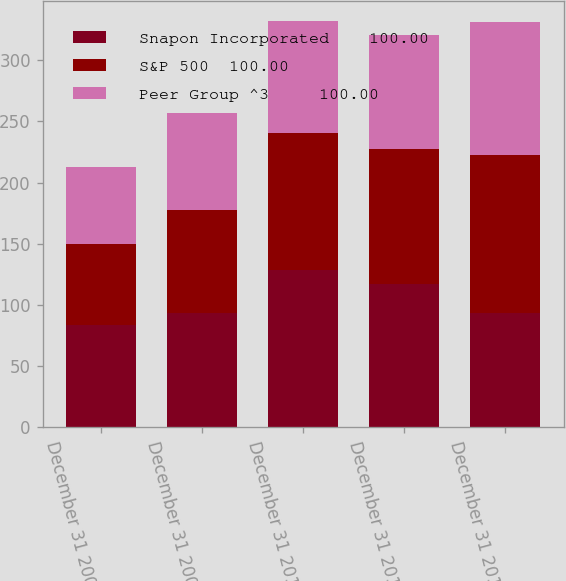Convert chart to OTSL. <chart><loc_0><loc_0><loc_500><loc_500><stacked_bar_chart><ecel><fcel>December 31 2008<fcel>December 31 2009<fcel>December 31 2010<fcel>December 31 2011<fcel>December 31 2012<nl><fcel>Snapon Incorporated    100.00<fcel>83.66<fcel>93.2<fcel>128.21<fcel>117.47<fcel>93.405<nl><fcel>S&P 500  100.00<fcel>66.15<fcel>84.12<fcel>112.02<fcel>109.7<fcel>129<nl><fcel>Peer Group ^3     100.00<fcel>63<fcel>79.67<fcel>91.67<fcel>93.61<fcel>108.59<nl></chart> 